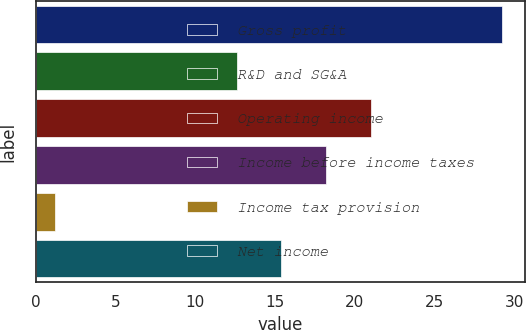<chart> <loc_0><loc_0><loc_500><loc_500><bar_chart><fcel>Gross profit<fcel>R&D and SG&A<fcel>Operating income<fcel>Income before income taxes<fcel>Income tax provision<fcel>Net income<nl><fcel>29.2<fcel>12.6<fcel>21<fcel>18.2<fcel>1.2<fcel>15.4<nl></chart> 